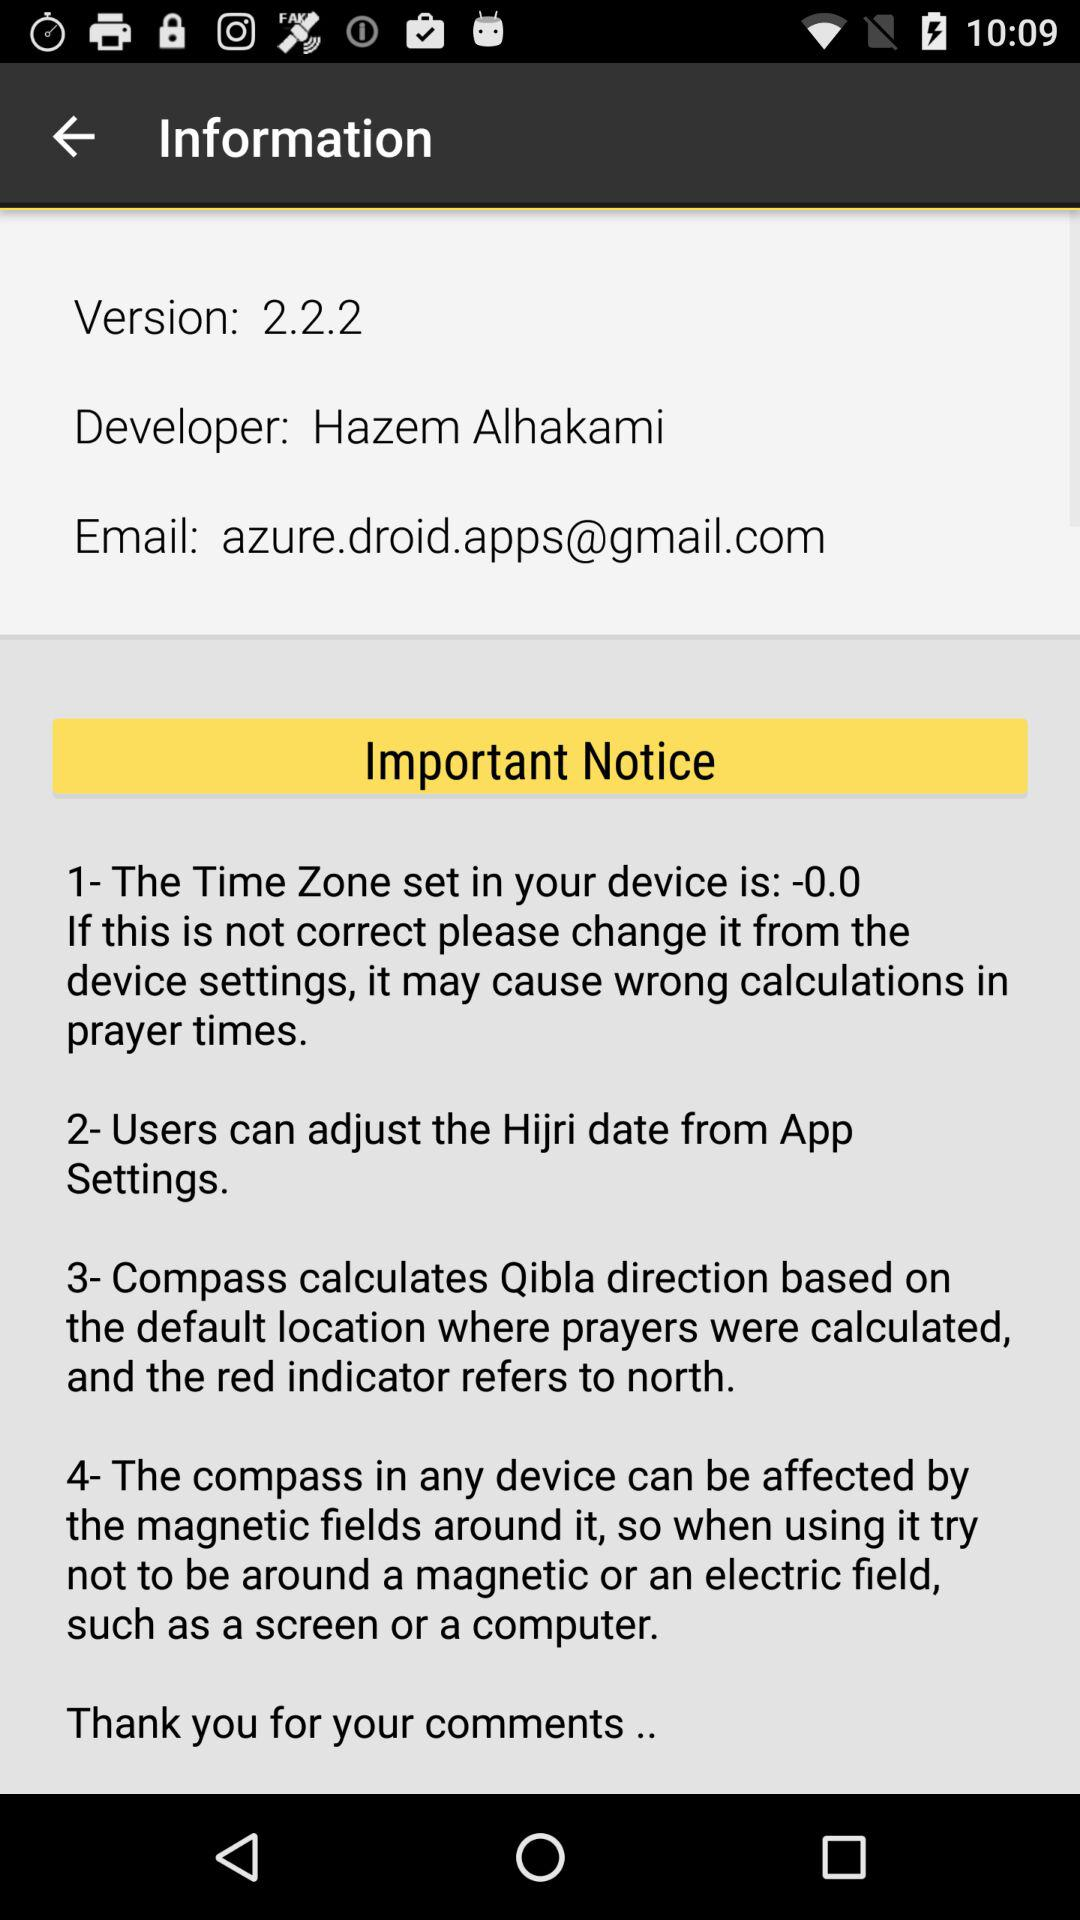What is the version of the app? The version of the app is 2.2.2. 